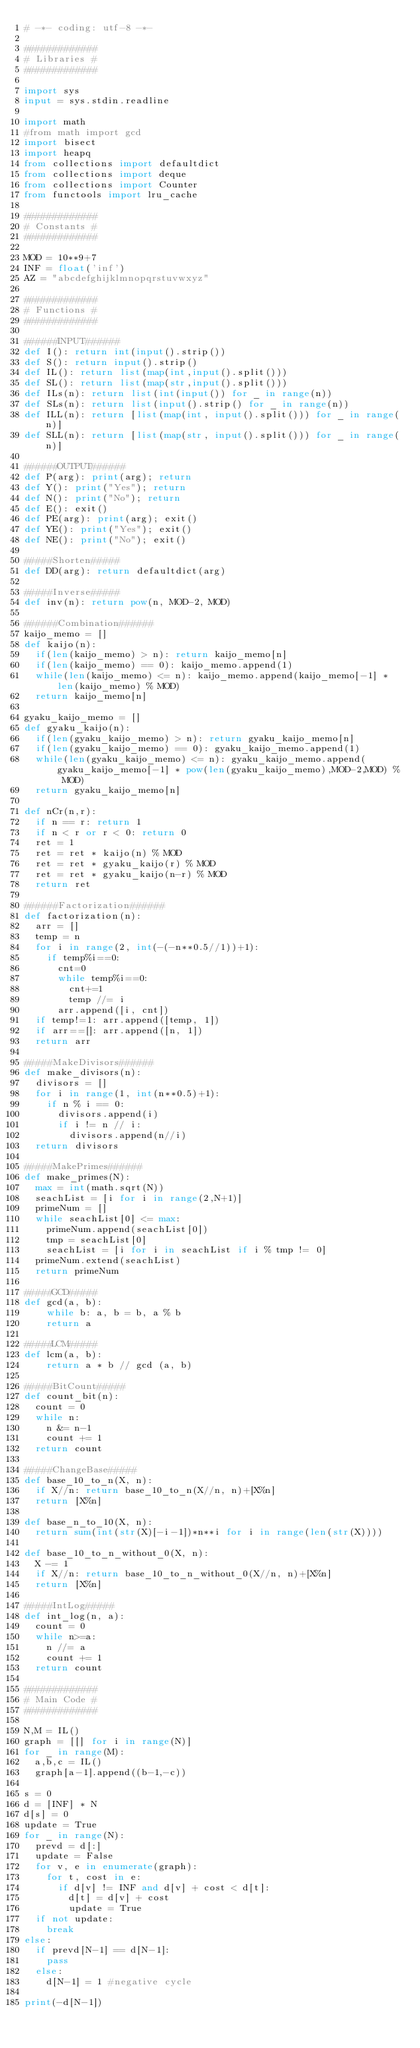<code> <loc_0><loc_0><loc_500><loc_500><_Python_># -*- coding: utf-8 -*-

#############
# Libraries #
#############

import sys
input = sys.stdin.readline

import math
#from math import gcd
import bisect
import heapq
from collections import defaultdict
from collections import deque
from collections import Counter
from functools import lru_cache

#############
# Constants #
#############

MOD = 10**9+7
INF = float('inf')
AZ = "abcdefghijklmnopqrstuvwxyz"

#############
# Functions #
#############

######INPUT######
def I(): return int(input().strip())
def S(): return input().strip()
def IL(): return list(map(int,input().split()))
def SL(): return list(map(str,input().split()))
def ILs(n): return list(int(input()) for _ in range(n))
def SLs(n): return list(input().strip() for _ in range(n))
def ILL(n): return [list(map(int, input().split())) for _ in range(n)]
def SLL(n): return [list(map(str, input().split())) for _ in range(n)]

######OUTPUT######
def P(arg): print(arg); return
def Y(): print("Yes"); return
def N(): print("No"); return
def E(): exit()
def PE(arg): print(arg); exit()
def YE(): print("Yes"); exit()
def NE(): print("No"); exit()

#####Shorten#####
def DD(arg): return defaultdict(arg)

#####Inverse#####
def inv(n): return pow(n, MOD-2, MOD)

######Combination######
kaijo_memo = []
def kaijo(n):
  if(len(kaijo_memo) > n): return kaijo_memo[n]
  if(len(kaijo_memo) == 0): kaijo_memo.append(1)
  while(len(kaijo_memo) <= n): kaijo_memo.append(kaijo_memo[-1] * len(kaijo_memo) % MOD)
  return kaijo_memo[n]

gyaku_kaijo_memo = []
def gyaku_kaijo(n):
  if(len(gyaku_kaijo_memo) > n): return gyaku_kaijo_memo[n]
  if(len(gyaku_kaijo_memo) == 0): gyaku_kaijo_memo.append(1)
  while(len(gyaku_kaijo_memo) <= n): gyaku_kaijo_memo.append(gyaku_kaijo_memo[-1] * pow(len(gyaku_kaijo_memo),MOD-2,MOD) % MOD)
  return gyaku_kaijo_memo[n]

def nCr(n,r):
  if n == r: return 1
  if n < r or r < 0: return 0
  ret = 1
  ret = ret * kaijo(n) % MOD
  ret = ret * gyaku_kaijo(r) % MOD
  ret = ret * gyaku_kaijo(n-r) % MOD
  return ret

######Factorization######
def factorization(n):
  arr = []
  temp = n
  for i in range(2, int(-(-n**0.5//1))+1):
    if temp%i==0:
      cnt=0
      while temp%i==0: 
        cnt+=1 
        temp //= i
      arr.append([i, cnt])
  if temp!=1: arr.append([temp, 1])
  if arr==[]: arr.append([n, 1])
  return arr

#####MakeDivisors######
def make_divisors(n):
  divisors = []
  for i in range(1, int(n**0.5)+1):
    if n % i == 0:
      divisors.append(i)
      if i != n // i: 
        divisors.append(n//i)
  return divisors

#####MakePrimes######
def make_primes(N):
  max = int(math.sqrt(N))
  seachList = [i for i in range(2,N+1)]
  primeNum = []
  while seachList[0] <= max:
    primeNum.append(seachList[0])
    tmp = seachList[0]
    seachList = [i for i in seachList if i % tmp != 0]
  primeNum.extend(seachList)
  return primeNum

#####GCD#####
def gcd(a, b):
    while b: a, b = b, a % b
    return a

#####LCM#####
def lcm(a, b):
    return a * b // gcd (a, b)

#####BitCount#####
def count_bit(n):
  count = 0
  while n:
    n &= n-1
    count += 1
  return count

#####ChangeBase#####
def base_10_to_n(X, n):
  if X//n: return base_10_to_n(X//n, n)+[X%n]
  return [X%n]

def base_n_to_10(X, n):
  return sum(int(str(X)[-i-1])*n**i for i in range(len(str(X))))

def base_10_to_n_without_0(X, n):
  X -= 1
  if X//n: return base_10_to_n_without_0(X//n, n)+[X%n]
  return [X%n]

#####IntLog#####
def int_log(n, a):
  count = 0
  while n>=a:
    n //= a
    count += 1
  return count

#############
# Main Code #
#############

N,M = IL()
graph = [[] for i in range(N)]
for _ in range(M):
  a,b,c = IL()
  graph[a-1].append((b-1,-c))
  
s = 0
d = [INF] * N
d[s] = 0
update = True
for _ in range(N):
  prevd = d[:]
  update = False
  for v, e in enumerate(graph):
    for t, cost in e:
      if d[v] != INF and d[v] + cost < d[t]:
        d[t] = d[v] + cost
        update = True
  if not update:
    break
else:
  if prevd[N-1] == d[N-1]:
    pass
  else:
    d[N-1] = 1 #negative cycle  
  
print(-d[N-1])</code> 